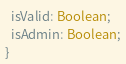Convert code to text. <code><loc_0><loc_0><loc_500><loc_500><_TypeScript_>  isValid: Boolean;
  isAdmin: Boolean;
}
</code> 